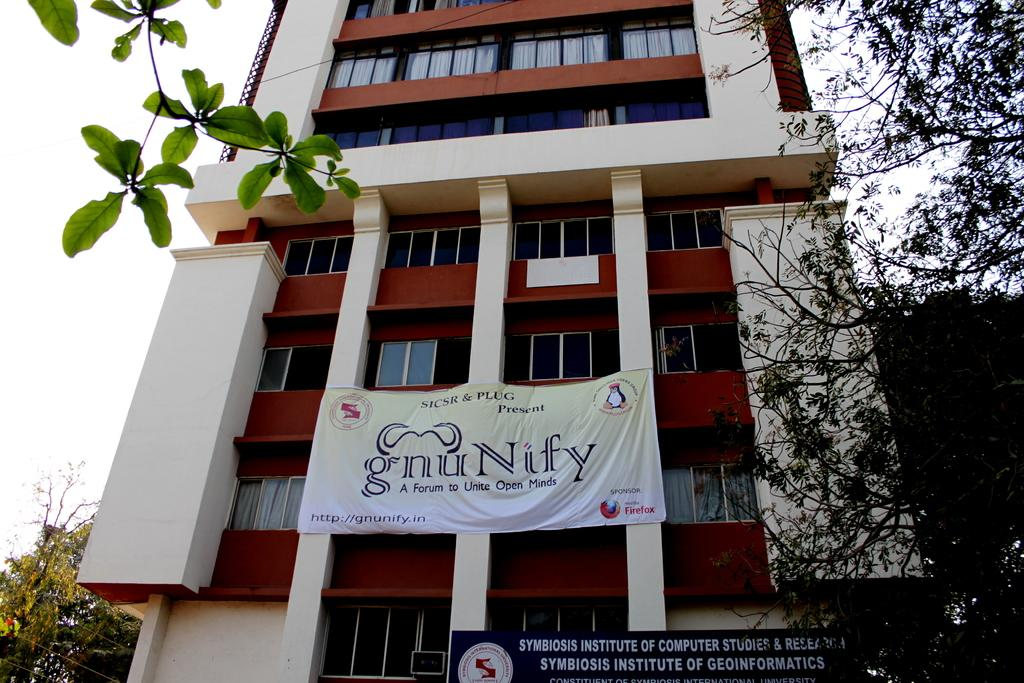What type of structure is visible in the image? There is a building in the image. What other natural elements can be seen in the image? There are trees in the image. Are there any signs or notices visible in the image? Yes, there is a board with text and a banner with text in the image. How would you describe the weather in the image? The sky is cloudy in the image. What type of dinner is being served in the image? There is no dinner present in the image; it features a building, trees, a board with text, a banner with text, and a cloudy sky. 